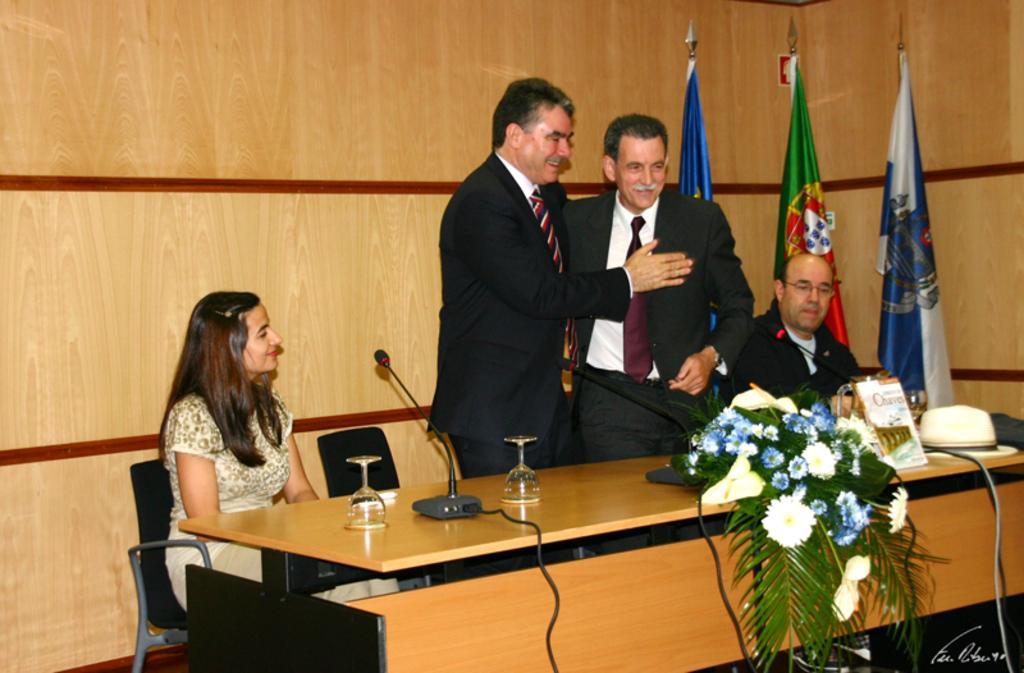Describe this image in one or two sentences. In this image I can see a group of people among them few people sitting on a chair and few are standing in front of a table. I can see there are few flags and some objects on the table. 